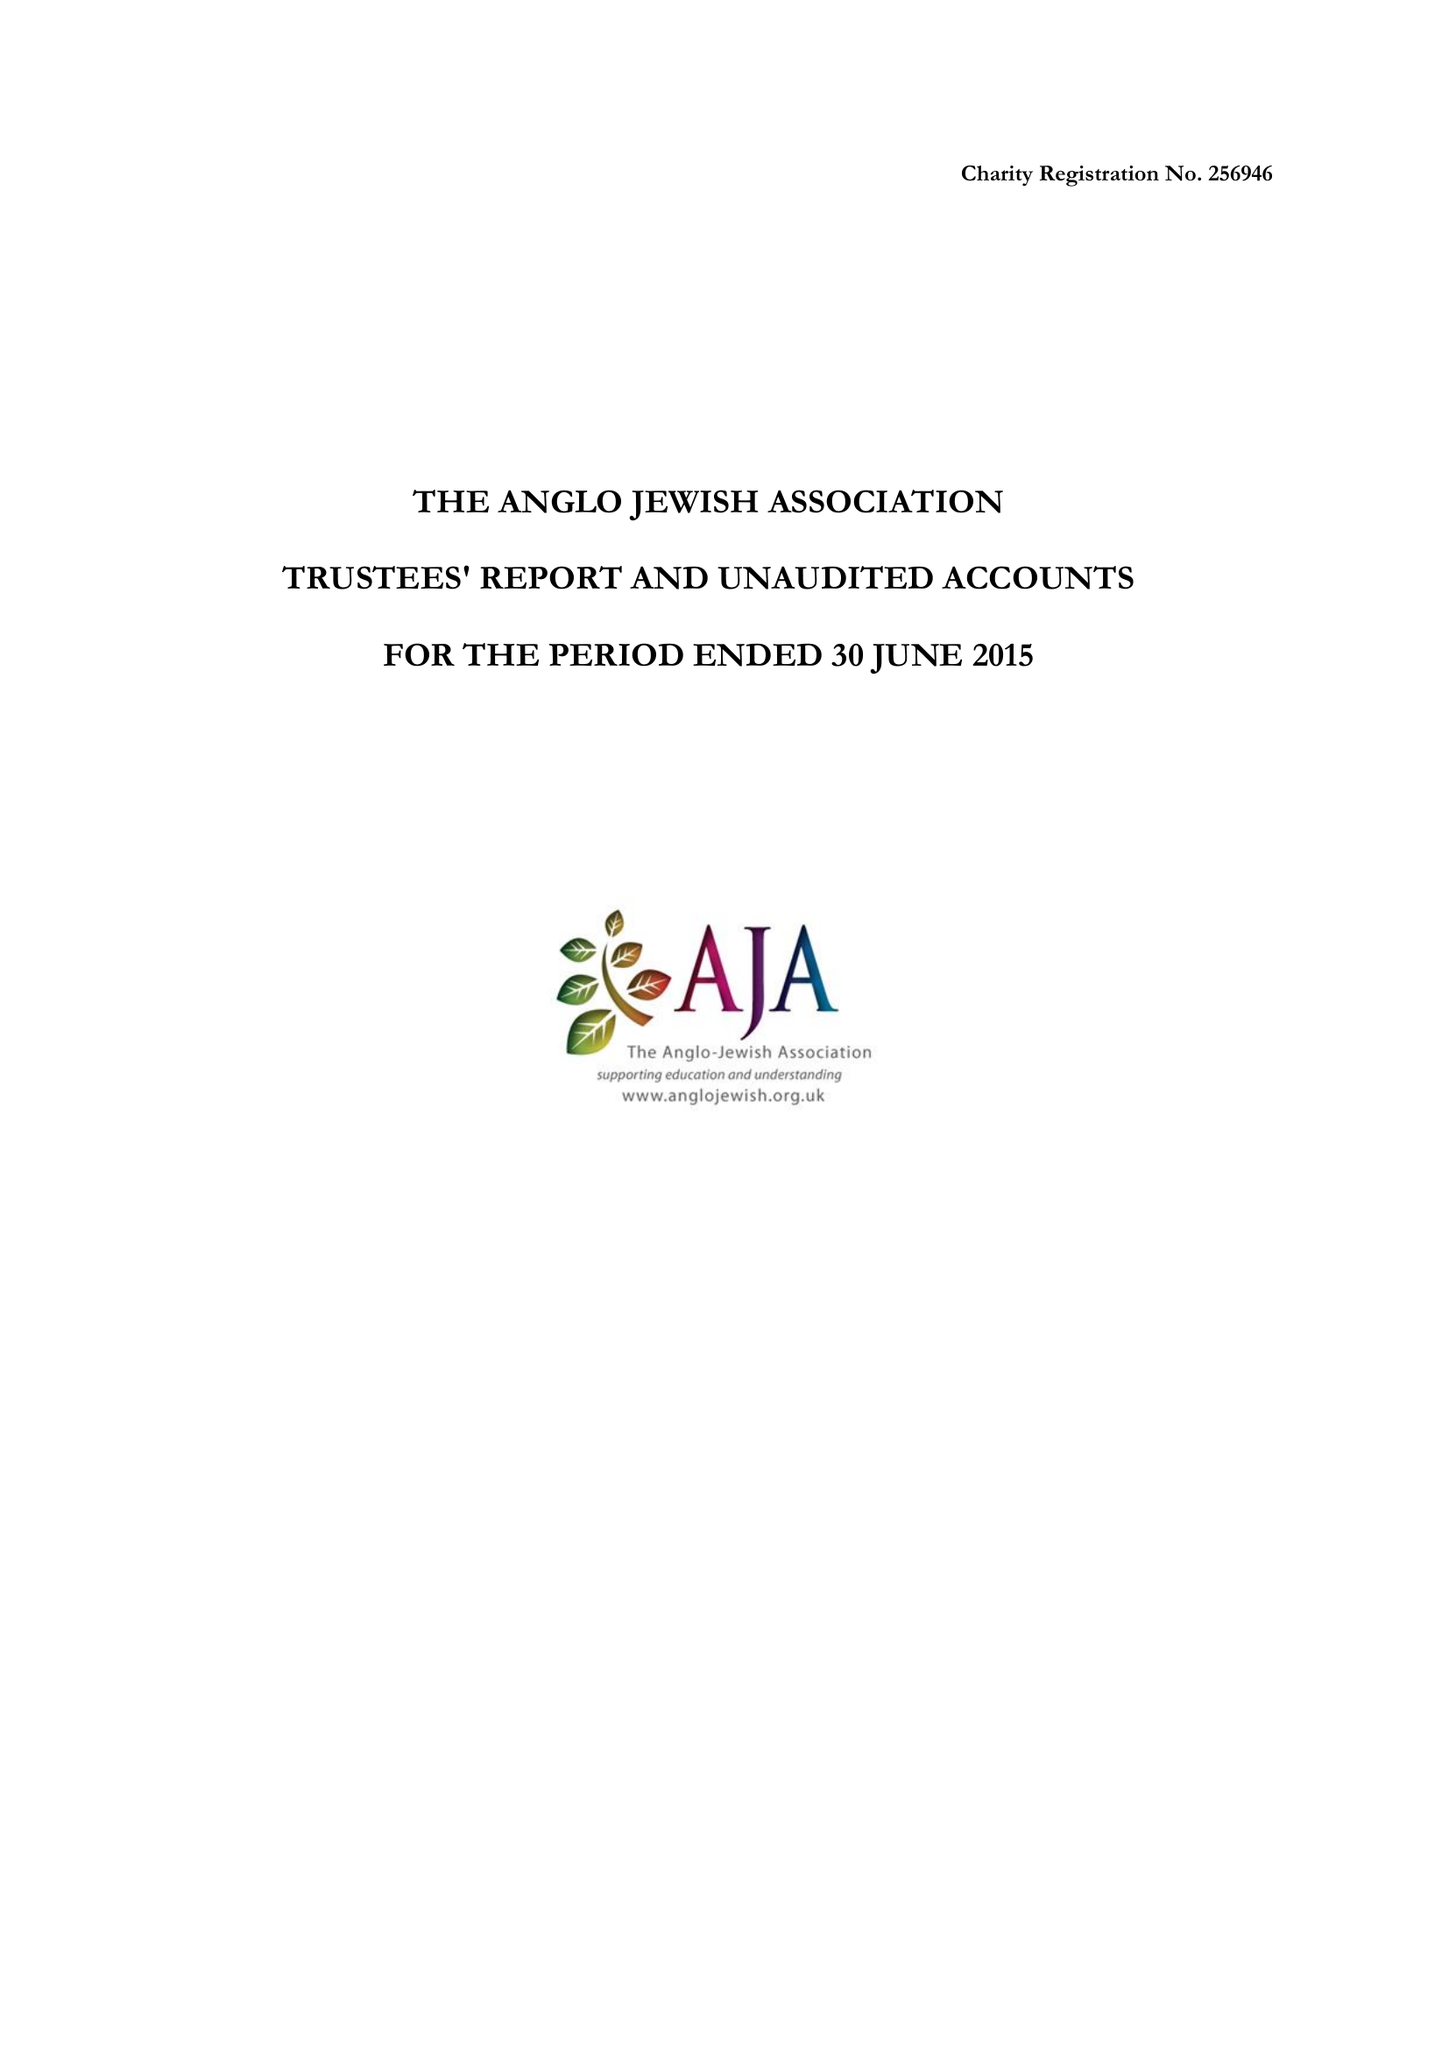What is the value for the charity_name?
Answer the question using a single word or phrase. The Anglo Jewish Association 